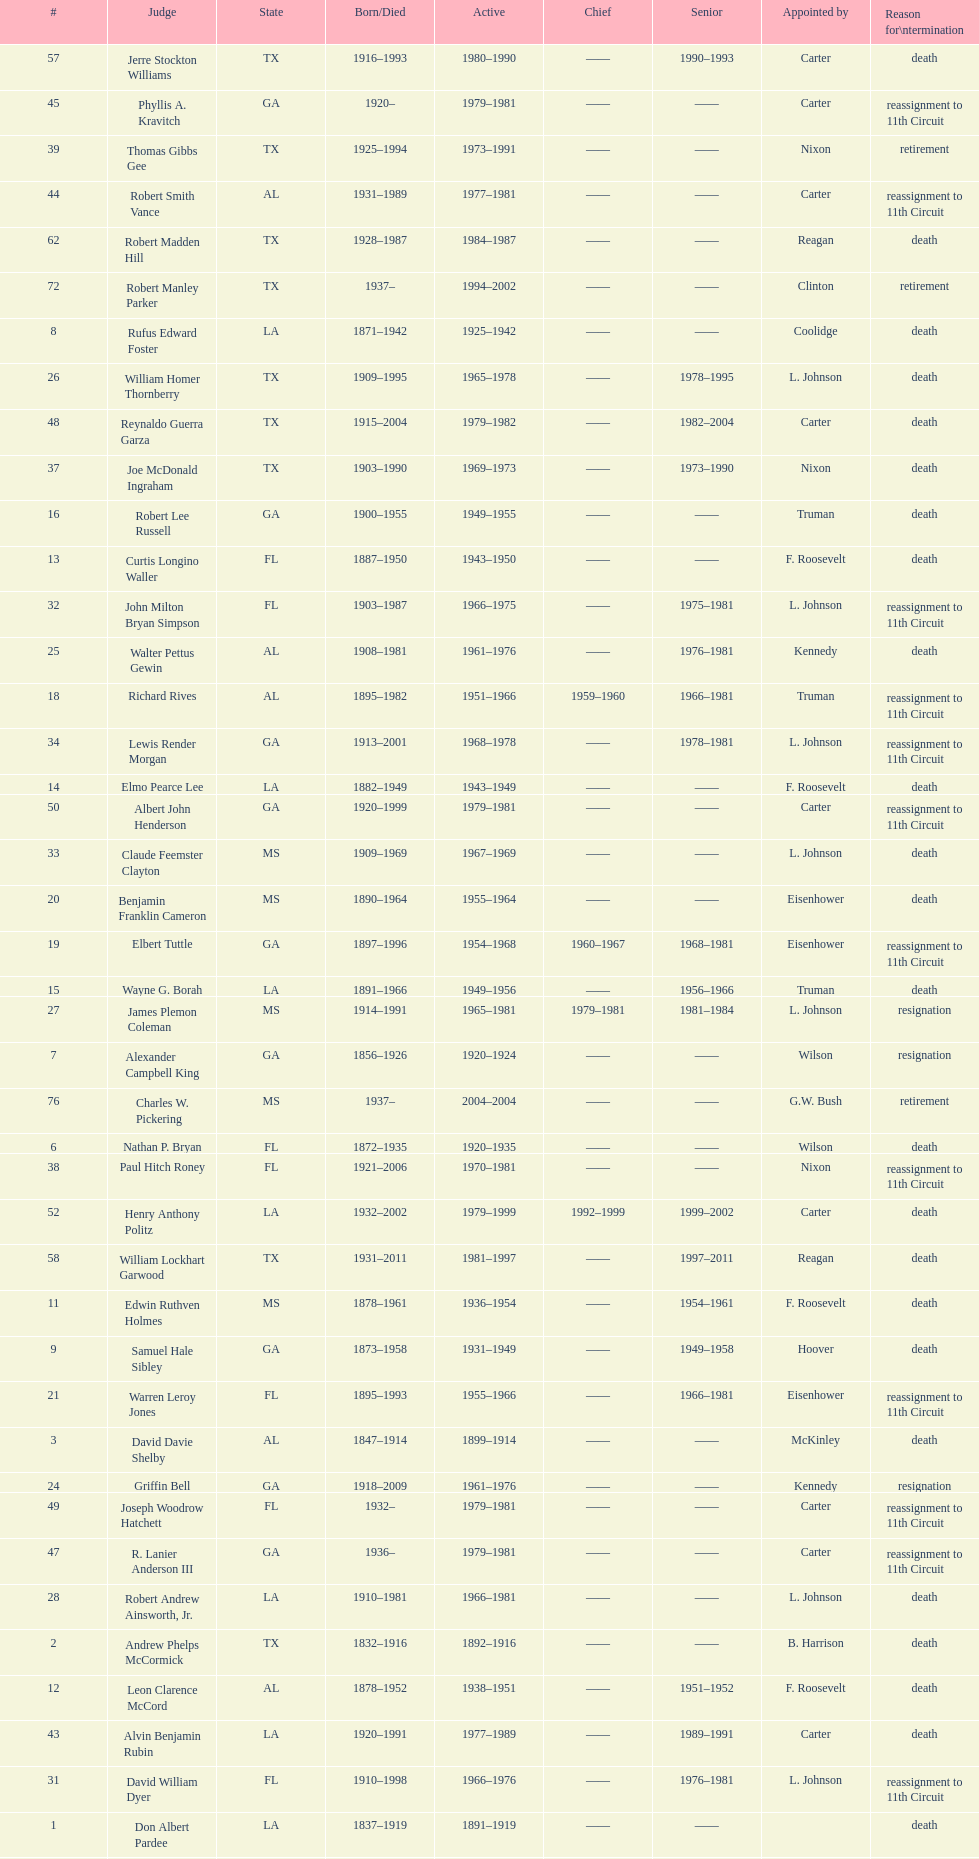How many judges served as chief total? 8. Help me parse the entirety of this table. {'header': ['#', 'Judge', 'State', 'Born/Died', 'Active', 'Chief', 'Senior', 'Appointed by', 'Reason for\\ntermination'], 'rows': [['57', 'Jerre Stockton Williams', 'TX', '1916–1993', '1980–1990', '——', '1990–1993', 'Carter', 'death'], ['45', 'Phyllis A. Kravitch', 'GA', '1920–', '1979–1981', '——', '——', 'Carter', 'reassignment to 11th Circuit'], ['39', 'Thomas Gibbs Gee', 'TX', '1925–1994', '1973–1991', '——', '——', 'Nixon', 'retirement'], ['44', 'Robert Smith Vance', 'AL', '1931–1989', '1977–1981', '——', '——', 'Carter', 'reassignment to 11th Circuit'], ['62', 'Robert Madden Hill', 'TX', '1928–1987', '1984–1987', '——', '——', 'Reagan', 'death'], ['72', 'Robert Manley Parker', 'TX', '1937–', '1994–2002', '——', '——', 'Clinton', 'retirement'], ['8', 'Rufus Edward Foster', 'LA', '1871–1942', '1925–1942', '——', '——', 'Coolidge', 'death'], ['26', 'William Homer Thornberry', 'TX', '1909–1995', '1965–1978', '——', '1978–1995', 'L. Johnson', 'death'], ['48', 'Reynaldo Guerra Garza', 'TX', '1915–2004', '1979–1982', '——', '1982–2004', 'Carter', 'death'], ['37', 'Joe McDonald Ingraham', 'TX', '1903–1990', '1969–1973', '——', '1973–1990', 'Nixon', 'death'], ['16', 'Robert Lee Russell', 'GA', '1900–1955', '1949–1955', '——', '——', 'Truman', 'death'], ['13', 'Curtis Longino Waller', 'FL', '1887–1950', '1943–1950', '——', '——', 'F. Roosevelt', 'death'], ['32', 'John Milton Bryan Simpson', 'FL', '1903–1987', '1966–1975', '——', '1975–1981', 'L. Johnson', 'reassignment to 11th Circuit'], ['25', 'Walter Pettus Gewin', 'AL', '1908–1981', '1961–1976', '——', '1976–1981', 'Kennedy', 'death'], ['18', 'Richard Rives', 'AL', '1895–1982', '1951–1966', '1959–1960', '1966–1981', 'Truman', 'reassignment to 11th Circuit'], ['34', 'Lewis Render Morgan', 'GA', '1913–2001', '1968–1978', '——', '1978–1981', 'L. Johnson', 'reassignment to 11th Circuit'], ['14', 'Elmo Pearce Lee', 'LA', '1882–1949', '1943–1949', '——', '——', 'F. Roosevelt', 'death'], ['50', 'Albert John Henderson', 'GA', '1920–1999', '1979–1981', '——', '——', 'Carter', 'reassignment to 11th Circuit'], ['33', 'Claude Feemster Clayton', 'MS', '1909–1969', '1967–1969', '——', '——', 'L. Johnson', 'death'], ['20', 'Benjamin Franklin Cameron', 'MS', '1890–1964', '1955–1964', '——', '——', 'Eisenhower', 'death'], ['19', 'Elbert Tuttle', 'GA', '1897–1996', '1954–1968', '1960–1967', '1968–1981', 'Eisenhower', 'reassignment to 11th Circuit'], ['15', 'Wayne G. Borah', 'LA', '1891–1966', '1949–1956', '——', '1956–1966', 'Truman', 'death'], ['27', 'James Plemon Coleman', 'MS', '1914–1991', '1965–1981', '1979–1981', '1981–1984', 'L. Johnson', 'resignation'], ['7', 'Alexander Campbell King', 'GA', '1856–1926', '1920–1924', '——', '——', 'Wilson', 'resignation'], ['76', 'Charles W. Pickering', 'MS', '1937–', '2004–2004', '——', '——', 'G.W. Bush', 'retirement'], ['6', 'Nathan P. Bryan', 'FL', '1872–1935', '1920–1935', '——', '——', 'Wilson', 'death'], ['38', 'Paul Hitch Roney', 'FL', '1921–2006', '1970–1981', '——', '——', 'Nixon', 'reassignment to 11th Circuit'], ['52', 'Henry Anthony Politz', 'LA', '1932–2002', '1979–1999', '1992–1999', '1999–2002', 'Carter', 'death'], ['58', 'William Lockhart Garwood', 'TX', '1931–2011', '1981–1997', '——', '1997–2011', 'Reagan', 'death'], ['11', 'Edwin Ruthven Holmes', 'MS', '1878–1961', '1936–1954', '——', '1954–1961', 'F. Roosevelt', 'death'], ['9', 'Samuel Hale Sibley', 'GA', '1873–1958', '1931–1949', '——', '1949–1958', 'Hoover', 'death'], ['21', 'Warren Leroy Jones', 'FL', '1895–1993', '1955–1966', '——', '1966–1981', 'Eisenhower', 'reassignment to 11th Circuit'], ['3', 'David Davie Shelby', 'AL', '1847–1914', '1899–1914', '——', '——', 'McKinley', 'death'], ['24', 'Griffin Bell', 'GA', '1918–2009', '1961–1976', '——', '——', 'Kennedy', 'resignation'], ['49', 'Joseph Woodrow Hatchett', 'FL', '1932–', '1979–1981', '——', '——', 'Carter', 'reassignment to 11th Circuit'], ['47', 'R. Lanier Anderson III', 'GA', '1936–', '1979–1981', '——', '——', 'Carter', 'reassignment to 11th Circuit'], ['28', 'Robert Andrew Ainsworth, Jr.', 'LA', '1910–1981', '1966–1981', '——', '——', 'L. Johnson', 'death'], ['2', 'Andrew Phelps McCormick', 'TX', '1832–1916', '1892–1916', '——', '——', 'B. Harrison', 'death'], ['12', 'Leon Clarence McCord', 'AL', '1878–1952', '1938–1951', '——', '1951–1952', 'F. Roosevelt', 'death'], ['43', 'Alvin Benjamin Rubin', 'LA', '1920–1991', '1977–1989', '——', '1989–1991', 'Carter', 'death'], ['31', 'David William Dyer', 'FL', '1910–1998', '1966–1976', '——', '1976–1981', 'L. Johnson', 'reassignment to 11th Circuit'], ['1', 'Don Albert Pardee', 'LA', '1837–1919', '1891–1919', '——', '——', '', 'death'], ['46', 'Frank Minis Johnson', 'AL', '1918–1999', '1979–1981', '——', '——', 'Carter', 'reassignment to 11th Circuit'], ['54', 'Samuel D. Johnson, Jr.', 'TX', '1920–2002', '1979–1991', '——', '1991–2002', 'Carter', 'death'], ['17', 'Louie Willard Strum', 'FL', '1890–1954', '1950–1954', '——', '——', 'Truman', 'death'], ['56', 'Thomas Alonzo Clark', 'GA', '1920–2005', '1979–1981', '——', '——', 'Carter', 'reassignment to 11th Circuit'], ['29', 'John Cooper Godbold', 'AL', '1920–2009', '1966–1981', '1981–1981', '——', 'L. Johnson', 'reassignment to 11th Circuit'], ['30', 'Irving Loeb Goldberg', 'TX', '1906–1995', '1966–1980', '——', '1980–1995', 'L. Johnson', 'death'], ['42', 'Peter Thorp Fay', 'FL', '1929–', '1976–1981', '——', '——', 'Ford', 'reassignment to 11th Circuit'], ['23', 'John Minor Wisdom', 'LA', '1905–1999', '1957–1977', '——', '1977–1999', 'Eisenhower', 'death'], ['35', 'Harold Carswell', 'FL', '1919–1992', '1969–1970', '——', '——', 'Nixon', 'resignation'], ['65', 'John Malcolm Duhé, Jr.', 'LA', '1933-', '1988–1999', '——', '1999–2011', 'Reagan', 'retirement'], ['36', 'Charles Clark', 'MS', '1925–2011', '1969–1992', '1981–1992', '——', 'Nixon', 'retirement'], ['55', 'Albert Tate, Jr.', 'LA', '1920–1986', '1979–1986', '——', '——', 'Carter', 'death'], ['22', 'John Robert Brown', 'TX', '1909–1984', '1955–1984', '1967–1979', '1984–1993', 'Eisenhower', 'death'], ['40', 'Gerald Bard Tjoflat', 'FL', '1929–', '1975–1981', '——', '——', 'Ford', 'reassignment to 11th Circuit'], ['4', 'Richard Wilde Walker, Jr.', 'AL', '1857–1936', '1914–1930', '——', '1930–1936', 'Wilson', 'death'], ['5', 'Robert Lynn Batts', 'TX', '1864–1935', '1917–1919', '——', '——', 'Wilson', 'resignation'], ['41', 'James Clinkscales Hill', 'GA', '1924–', '1976–1981', '——', '——', 'Ford', 'reassignment to 11th Circuit'], ['10', 'Joseph Chappell Hutcheson, Jr.', 'TX', '1879–1973', '1931–1964', '1948–1959', '1964–1973', 'Hoover', 'death']]} 